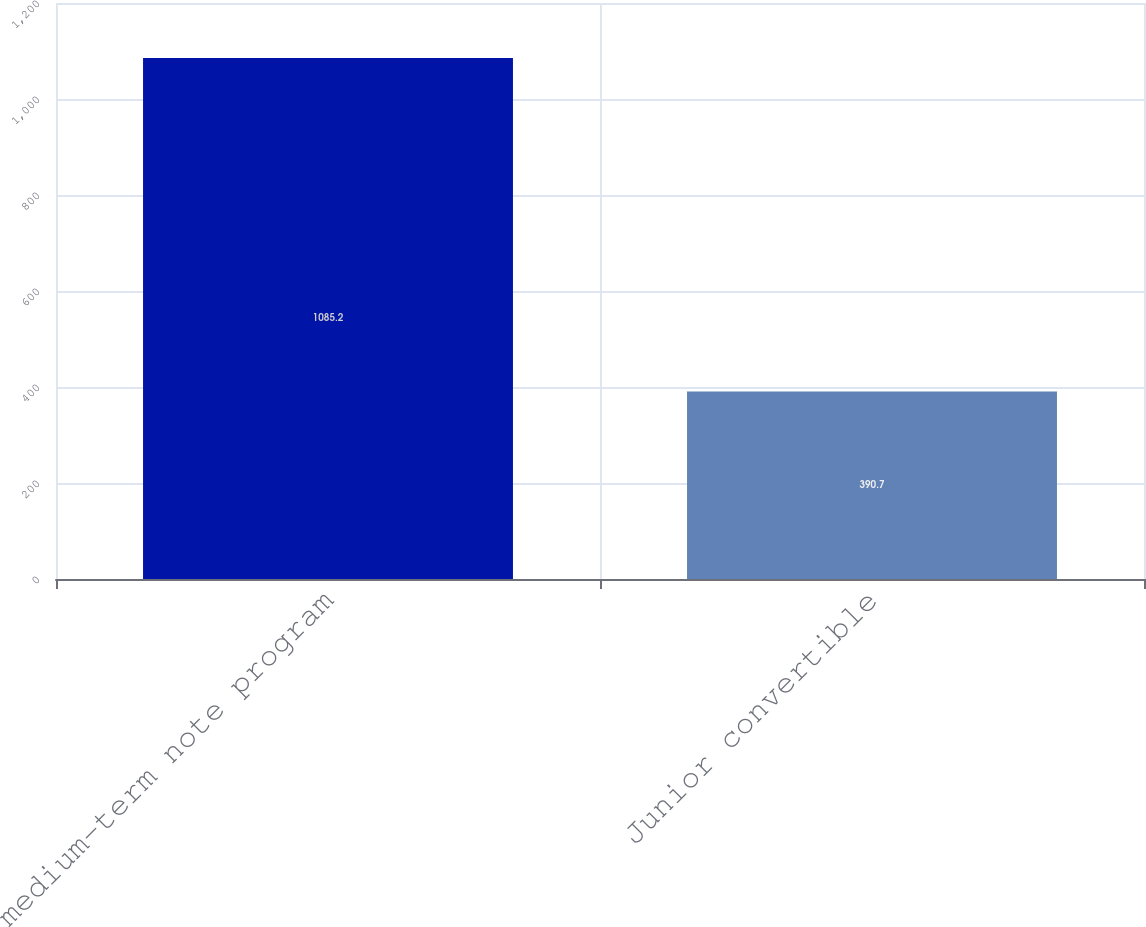<chart> <loc_0><loc_0><loc_500><loc_500><bar_chart><fcel>medium-term note program<fcel>Junior convertible<nl><fcel>1085.2<fcel>390.7<nl></chart> 